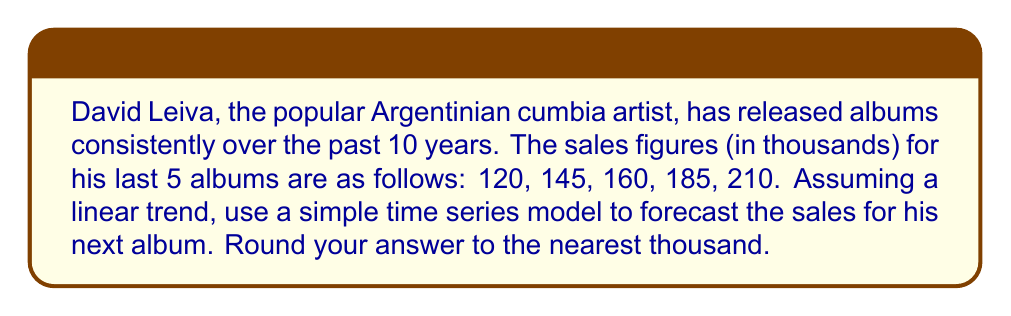Give your solution to this math problem. To forecast the sales of David Leiva's next album using a simple time series model with a linear trend, we'll follow these steps:

1. Let's define our time variable $t$ and sales variable $y$:
   $t = 1, 2, 3, 4, 5$ (for the 5 albums)
   $y = 120, 145, 160, 185, 210$ (sales in thousands)

2. We'll use the linear regression model: $y = \beta_0 + \beta_1t + \epsilon$

3. To find $\beta_0$ and $\beta_1$, we'll use these formulas:
   $$\beta_1 = \frac{n\sum ty - \sum t \sum y}{n\sum t^2 - (\sum t)^2}$$
   $$\beta_0 = \bar{y} - \beta_1\bar{t}$$

4. Calculate the sums:
   $\sum t = 1 + 2 + 3 + 4 + 5 = 15$
   $\sum y = 120 + 145 + 160 + 185 + 210 = 820$
   $\sum ty = 1(120) + 2(145) + 3(160) + 4(185) + 5(210) = 2690$
   $\sum t^2 = 1^2 + 2^2 + 3^2 + 4^2 + 5^2 = 55$

5. Calculate $\beta_1$:
   $$\beta_1 = \frac{5(2690) - 15(820)}{5(55) - 15^2} = \frac{13450 - 12300}{275 - 225} = \frac{1150}{50} = 23$$

6. Calculate the means:
   $\bar{t} = \frac{15}{5} = 3$
   $\bar{y} = \frac{820}{5} = 164$

7. Calculate $\beta_0$:
   $$\beta_0 = 164 - 23(3) = 164 - 69 = 95$$

8. Our linear model is: $y = 95 + 23t$

9. To forecast the next album (t = 6):
   $y = 95 + 23(6) = 95 + 138 = 233$

Rounding to the nearest thousand, we get 233,000 sales for the next album.
Answer: 233,000 album sales 